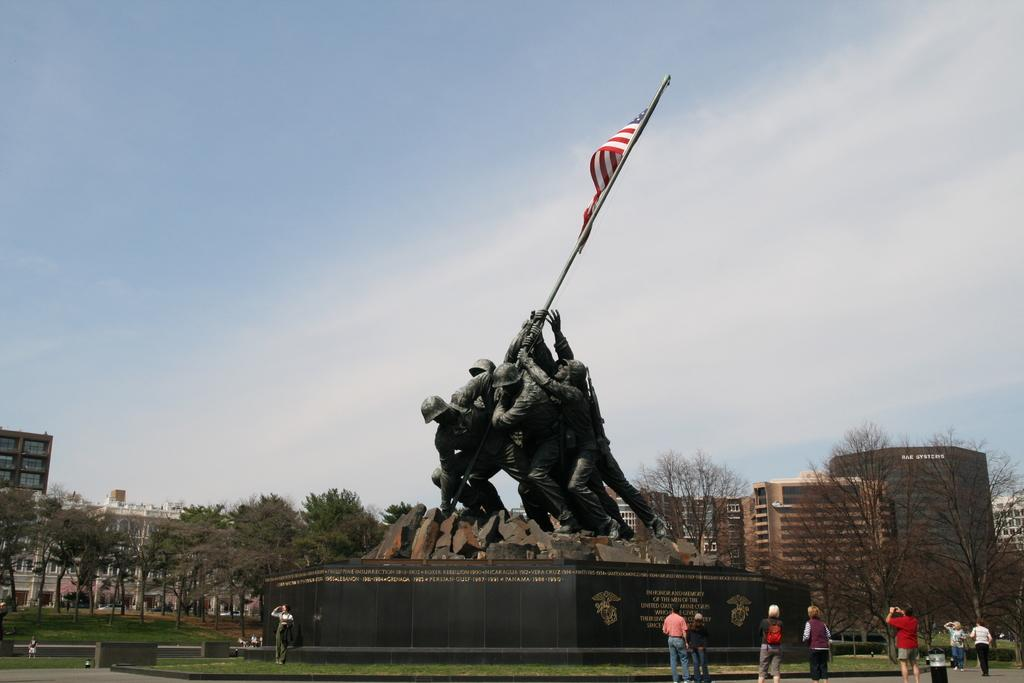What is located in the middle of the image? There are statues and a flag in the middle of the image. What can be seen in the background of the image? There are buildings and trees in the background of the image. Are there any people present in the image? Yes, there is a group of people in the image. What type of skin can be seen on the statues in the image? The statues in the image are not made of skin; they are likely made of stone or another material. Can you tell me how many flowers are present in the image? There are no flowers visible in the image. 